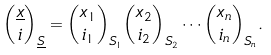Convert formula to latex. <formula><loc_0><loc_0><loc_500><loc_500>\binom { \underline { x } } { i } _ { \underline { S } } = \binom { x _ { 1 } } { i _ { 1 } } _ { S _ { 1 } } \binom { x _ { 2 } } { i _ { 2 } } _ { S _ { 2 } } \cdots \binom { x _ { n } } { i _ { n } } _ { S _ { n } } .</formula> 